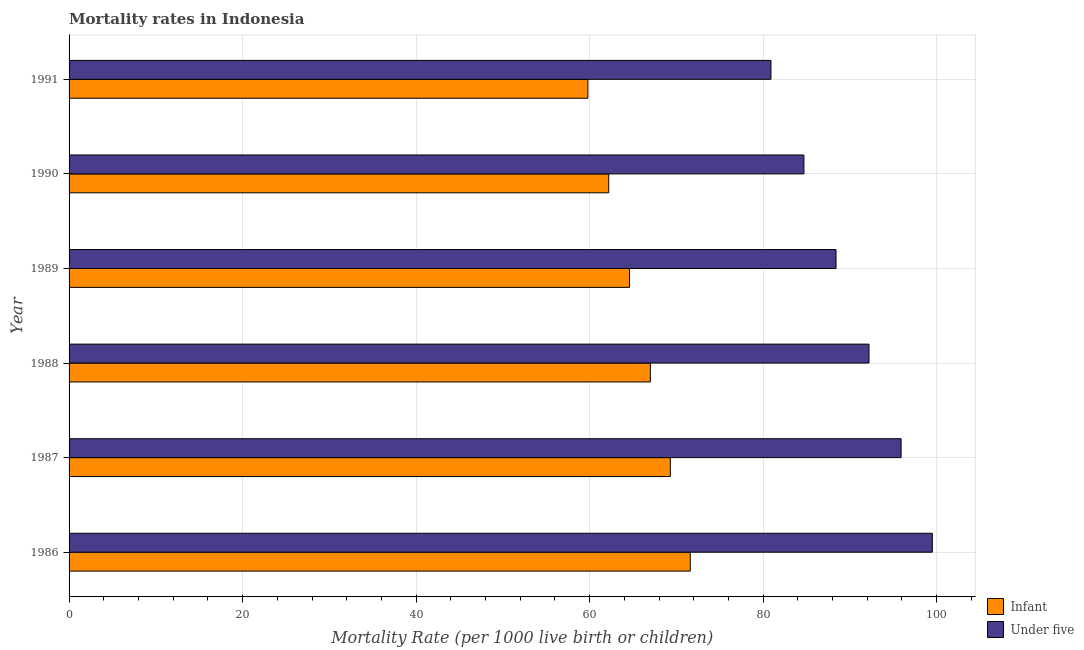Are the number of bars per tick equal to the number of legend labels?
Provide a succinct answer. Yes. Are the number of bars on each tick of the Y-axis equal?
Give a very brief answer. Yes. How many bars are there on the 4th tick from the top?
Keep it short and to the point. 2. What is the infant mortality rate in 1991?
Provide a short and direct response. 59.8. Across all years, what is the maximum under-5 mortality rate?
Offer a very short reply. 99.5. Across all years, what is the minimum infant mortality rate?
Your response must be concise. 59.8. What is the total infant mortality rate in the graph?
Offer a very short reply. 394.5. What is the difference between the under-5 mortality rate in 1989 and the infant mortality rate in 1988?
Your answer should be very brief. 21.4. What is the average under-5 mortality rate per year?
Your response must be concise. 90.27. In the year 1991, what is the difference between the under-5 mortality rate and infant mortality rate?
Offer a very short reply. 21.1. In how many years, is the infant mortality rate greater than 88 ?
Provide a short and direct response. 0. What is the ratio of the under-5 mortality rate in 1986 to that in 1991?
Keep it short and to the point. 1.23. Is the difference between the under-5 mortality rate in 1986 and 1989 greater than the difference between the infant mortality rate in 1986 and 1989?
Your answer should be very brief. Yes. What does the 2nd bar from the top in 1986 represents?
Provide a succinct answer. Infant. What does the 2nd bar from the bottom in 1991 represents?
Make the answer very short. Under five. How many bars are there?
Provide a short and direct response. 12. How many years are there in the graph?
Offer a very short reply. 6. What is the difference between two consecutive major ticks on the X-axis?
Offer a very short reply. 20. Are the values on the major ticks of X-axis written in scientific E-notation?
Provide a short and direct response. No. Does the graph contain any zero values?
Provide a succinct answer. No. Does the graph contain grids?
Your response must be concise. Yes. Where does the legend appear in the graph?
Provide a succinct answer. Bottom right. How many legend labels are there?
Make the answer very short. 2. How are the legend labels stacked?
Provide a short and direct response. Vertical. What is the title of the graph?
Offer a terse response. Mortality rates in Indonesia. What is the label or title of the X-axis?
Keep it short and to the point. Mortality Rate (per 1000 live birth or children). What is the label or title of the Y-axis?
Your answer should be compact. Year. What is the Mortality Rate (per 1000 live birth or children) of Infant in 1986?
Give a very brief answer. 71.6. What is the Mortality Rate (per 1000 live birth or children) of Under five in 1986?
Your answer should be compact. 99.5. What is the Mortality Rate (per 1000 live birth or children) of Infant in 1987?
Your response must be concise. 69.3. What is the Mortality Rate (per 1000 live birth or children) of Under five in 1987?
Offer a very short reply. 95.9. What is the Mortality Rate (per 1000 live birth or children) of Under five in 1988?
Keep it short and to the point. 92.2. What is the Mortality Rate (per 1000 live birth or children) of Infant in 1989?
Make the answer very short. 64.6. What is the Mortality Rate (per 1000 live birth or children) of Under five in 1989?
Offer a very short reply. 88.4. What is the Mortality Rate (per 1000 live birth or children) in Infant in 1990?
Give a very brief answer. 62.2. What is the Mortality Rate (per 1000 live birth or children) in Under five in 1990?
Provide a succinct answer. 84.7. What is the Mortality Rate (per 1000 live birth or children) in Infant in 1991?
Your response must be concise. 59.8. What is the Mortality Rate (per 1000 live birth or children) in Under five in 1991?
Keep it short and to the point. 80.9. Across all years, what is the maximum Mortality Rate (per 1000 live birth or children) of Infant?
Give a very brief answer. 71.6. Across all years, what is the maximum Mortality Rate (per 1000 live birth or children) in Under five?
Make the answer very short. 99.5. Across all years, what is the minimum Mortality Rate (per 1000 live birth or children) in Infant?
Your response must be concise. 59.8. Across all years, what is the minimum Mortality Rate (per 1000 live birth or children) in Under five?
Your answer should be very brief. 80.9. What is the total Mortality Rate (per 1000 live birth or children) of Infant in the graph?
Keep it short and to the point. 394.5. What is the total Mortality Rate (per 1000 live birth or children) of Under five in the graph?
Keep it short and to the point. 541.6. What is the difference between the Mortality Rate (per 1000 live birth or children) in Under five in 1986 and that in 1987?
Your answer should be very brief. 3.6. What is the difference between the Mortality Rate (per 1000 live birth or children) in Infant in 1986 and that in 1988?
Offer a terse response. 4.6. What is the difference between the Mortality Rate (per 1000 live birth or children) in Under five in 1986 and that in 1989?
Keep it short and to the point. 11.1. What is the difference between the Mortality Rate (per 1000 live birth or children) of Infant in 1986 and that in 1990?
Provide a short and direct response. 9.4. What is the difference between the Mortality Rate (per 1000 live birth or children) in Under five in 1986 and that in 1990?
Ensure brevity in your answer.  14.8. What is the difference between the Mortality Rate (per 1000 live birth or children) in Under five in 1986 and that in 1991?
Give a very brief answer. 18.6. What is the difference between the Mortality Rate (per 1000 live birth or children) in Under five in 1987 and that in 1988?
Make the answer very short. 3.7. What is the difference between the Mortality Rate (per 1000 live birth or children) in Infant in 1987 and that in 1989?
Your answer should be compact. 4.7. What is the difference between the Mortality Rate (per 1000 live birth or children) of Under five in 1987 and that in 1989?
Offer a terse response. 7.5. What is the difference between the Mortality Rate (per 1000 live birth or children) in Infant in 1987 and that in 1990?
Provide a succinct answer. 7.1. What is the difference between the Mortality Rate (per 1000 live birth or children) in Infant in 1987 and that in 1991?
Give a very brief answer. 9.5. What is the difference between the Mortality Rate (per 1000 live birth or children) in Under five in 1988 and that in 1991?
Provide a short and direct response. 11.3. What is the difference between the Mortality Rate (per 1000 live birth or children) in Infant in 1989 and that in 1990?
Your response must be concise. 2.4. What is the difference between the Mortality Rate (per 1000 live birth or children) in Under five in 1989 and that in 1990?
Provide a succinct answer. 3.7. What is the difference between the Mortality Rate (per 1000 live birth or children) of Under five in 1989 and that in 1991?
Offer a very short reply. 7.5. What is the difference between the Mortality Rate (per 1000 live birth or children) of Infant in 1990 and that in 1991?
Offer a very short reply. 2.4. What is the difference between the Mortality Rate (per 1000 live birth or children) in Infant in 1986 and the Mortality Rate (per 1000 live birth or children) in Under five in 1987?
Offer a terse response. -24.3. What is the difference between the Mortality Rate (per 1000 live birth or children) of Infant in 1986 and the Mortality Rate (per 1000 live birth or children) of Under five in 1988?
Give a very brief answer. -20.6. What is the difference between the Mortality Rate (per 1000 live birth or children) in Infant in 1986 and the Mortality Rate (per 1000 live birth or children) in Under five in 1989?
Give a very brief answer. -16.8. What is the difference between the Mortality Rate (per 1000 live birth or children) of Infant in 1986 and the Mortality Rate (per 1000 live birth or children) of Under five in 1990?
Offer a very short reply. -13.1. What is the difference between the Mortality Rate (per 1000 live birth or children) in Infant in 1986 and the Mortality Rate (per 1000 live birth or children) in Under five in 1991?
Keep it short and to the point. -9.3. What is the difference between the Mortality Rate (per 1000 live birth or children) in Infant in 1987 and the Mortality Rate (per 1000 live birth or children) in Under five in 1988?
Provide a succinct answer. -22.9. What is the difference between the Mortality Rate (per 1000 live birth or children) of Infant in 1987 and the Mortality Rate (per 1000 live birth or children) of Under five in 1989?
Provide a short and direct response. -19.1. What is the difference between the Mortality Rate (per 1000 live birth or children) in Infant in 1987 and the Mortality Rate (per 1000 live birth or children) in Under five in 1990?
Your answer should be very brief. -15.4. What is the difference between the Mortality Rate (per 1000 live birth or children) of Infant in 1988 and the Mortality Rate (per 1000 live birth or children) of Under five in 1989?
Keep it short and to the point. -21.4. What is the difference between the Mortality Rate (per 1000 live birth or children) of Infant in 1988 and the Mortality Rate (per 1000 live birth or children) of Under five in 1990?
Provide a succinct answer. -17.7. What is the difference between the Mortality Rate (per 1000 live birth or children) in Infant in 1988 and the Mortality Rate (per 1000 live birth or children) in Under five in 1991?
Make the answer very short. -13.9. What is the difference between the Mortality Rate (per 1000 live birth or children) of Infant in 1989 and the Mortality Rate (per 1000 live birth or children) of Under five in 1990?
Offer a very short reply. -20.1. What is the difference between the Mortality Rate (per 1000 live birth or children) of Infant in 1989 and the Mortality Rate (per 1000 live birth or children) of Under five in 1991?
Make the answer very short. -16.3. What is the difference between the Mortality Rate (per 1000 live birth or children) in Infant in 1990 and the Mortality Rate (per 1000 live birth or children) in Under five in 1991?
Make the answer very short. -18.7. What is the average Mortality Rate (per 1000 live birth or children) in Infant per year?
Ensure brevity in your answer.  65.75. What is the average Mortality Rate (per 1000 live birth or children) of Under five per year?
Your answer should be very brief. 90.27. In the year 1986, what is the difference between the Mortality Rate (per 1000 live birth or children) in Infant and Mortality Rate (per 1000 live birth or children) in Under five?
Keep it short and to the point. -27.9. In the year 1987, what is the difference between the Mortality Rate (per 1000 live birth or children) of Infant and Mortality Rate (per 1000 live birth or children) of Under five?
Keep it short and to the point. -26.6. In the year 1988, what is the difference between the Mortality Rate (per 1000 live birth or children) in Infant and Mortality Rate (per 1000 live birth or children) in Under five?
Make the answer very short. -25.2. In the year 1989, what is the difference between the Mortality Rate (per 1000 live birth or children) in Infant and Mortality Rate (per 1000 live birth or children) in Under five?
Your answer should be compact. -23.8. In the year 1990, what is the difference between the Mortality Rate (per 1000 live birth or children) in Infant and Mortality Rate (per 1000 live birth or children) in Under five?
Give a very brief answer. -22.5. In the year 1991, what is the difference between the Mortality Rate (per 1000 live birth or children) of Infant and Mortality Rate (per 1000 live birth or children) of Under five?
Offer a terse response. -21.1. What is the ratio of the Mortality Rate (per 1000 live birth or children) in Infant in 1986 to that in 1987?
Give a very brief answer. 1.03. What is the ratio of the Mortality Rate (per 1000 live birth or children) in Under five in 1986 to that in 1987?
Your answer should be very brief. 1.04. What is the ratio of the Mortality Rate (per 1000 live birth or children) in Infant in 1986 to that in 1988?
Give a very brief answer. 1.07. What is the ratio of the Mortality Rate (per 1000 live birth or children) of Under five in 1986 to that in 1988?
Provide a succinct answer. 1.08. What is the ratio of the Mortality Rate (per 1000 live birth or children) in Infant in 1986 to that in 1989?
Provide a short and direct response. 1.11. What is the ratio of the Mortality Rate (per 1000 live birth or children) in Under five in 1986 to that in 1989?
Provide a succinct answer. 1.13. What is the ratio of the Mortality Rate (per 1000 live birth or children) in Infant in 1986 to that in 1990?
Provide a succinct answer. 1.15. What is the ratio of the Mortality Rate (per 1000 live birth or children) in Under five in 1986 to that in 1990?
Make the answer very short. 1.17. What is the ratio of the Mortality Rate (per 1000 live birth or children) of Infant in 1986 to that in 1991?
Keep it short and to the point. 1.2. What is the ratio of the Mortality Rate (per 1000 live birth or children) in Under five in 1986 to that in 1991?
Provide a succinct answer. 1.23. What is the ratio of the Mortality Rate (per 1000 live birth or children) in Infant in 1987 to that in 1988?
Your answer should be compact. 1.03. What is the ratio of the Mortality Rate (per 1000 live birth or children) in Under five in 1987 to that in 1988?
Offer a terse response. 1.04. What is the ratio of the Mortality Rate (per 1000 live birth or children) of Infant in 1987 to that in 1989?
Offer a terse response. 1.07. What is the ratio of the Mortality Rate (per 1000 live birth or children) of Under five in 1987 to that in 1989?
Make the answer very short. 1.08. What is the ratio of the Mortality Rate (per 1000 live birth or children) of Infant in 1987 to that in 1990?
Ensure brevity in your answer.  1.11. What is the ratio of the Mortality Rate (per 1000 live birth or children) in Under five in 1987 to that in 1990?
Your answer should be very brief. 1.13. What is the ratio of the Mortality Rate (per 1000 live birth or children) in Infant in 1987 to that in 1991?
Offer a terse response. 1.16. What is the ratio of the Mortality Rate (per 1000 live birth or children) in Under five in 1987 to that in 1991?
Your answer should be compact. 1.19. What is the ratio of the Mortality Rate (per 1000 live birth or children) of Infant in 1988 to that in 1989?
Your answer should be compact. 1.04. What is the ratio of the Mortality Rate (per 1000 live birth or children) in Under five in 1988 to that in 1989?
Keep it short and to the point. 1.04. What is the ratio of the Mortality Rate (per 1000 live birth or children) in Infant in 1988 to that in 1990?
Give a very brief answer. 1.08. What is the ratio of the Mortality Rate (per 1000 live birth or children) of Under five in 1988 to that in 1990?
Offer a very short reply. 1.09. What is the ratio of the Mortality Rate (per 1000 live birth or children) in Infant in 1988 to that in 1991?
Provide a short and direct response. 1.12. What is the ratio of the Mortality Rate (per 1000 live birth or children) of Under five in 1988 to that in 1991?
Your answer should be very brief. 1.14. What is the ratio of the Mortality Rate (per 1000 live birth or children) in Infant in 1989 to that in 1990?
Make the answer very short. 1.04. What is the ratio of the Mortality Rate (per 1000 live birth or children) in Under five in 1989 to that in 1990?
Your answer should be compact. 1.04. What is the ratio of the Mortality Rate (per 1000 live birth or children) in Infant in 1989 to that in 1991?
Ensure brevity in your answer.  1.08. What is the ratio of the Mortality Rate (per 1000 live birth or children) of Under five in 1989 to that in 1991?
Your answer should be compact. 1.09. What is the ratio of the Mortality Rate (per 1000 live birth or children) in Infant in 1990 to that in 1991?
Give a very brief answer. 1.04. What is the ratio of the Mortality Rate (per 1000 live birth or children) in Under five in 1990 to that in 1991?
Your answer should be very brief. 1.05. What is the difference between the highest and the second highest Mortality Rate (per 1000 live birth or children) of Infant?
Your answer should be compact. 2.3. What is the difference between the highest and the second highest Mortality Rate (per 1000 live birth or children) of Under five?
Provide a short and direct response. 3.6. What is the difference between the highest and the lowest Mortality Rate (per 1000 live birth or children) in Infant?
Ensure brevity in your answer.  11.8. What is the difference between the highest and the lowest Mortality Rate (per 1000 live birth or children) in Under five?
Keep it short and to the point. 18.6. 